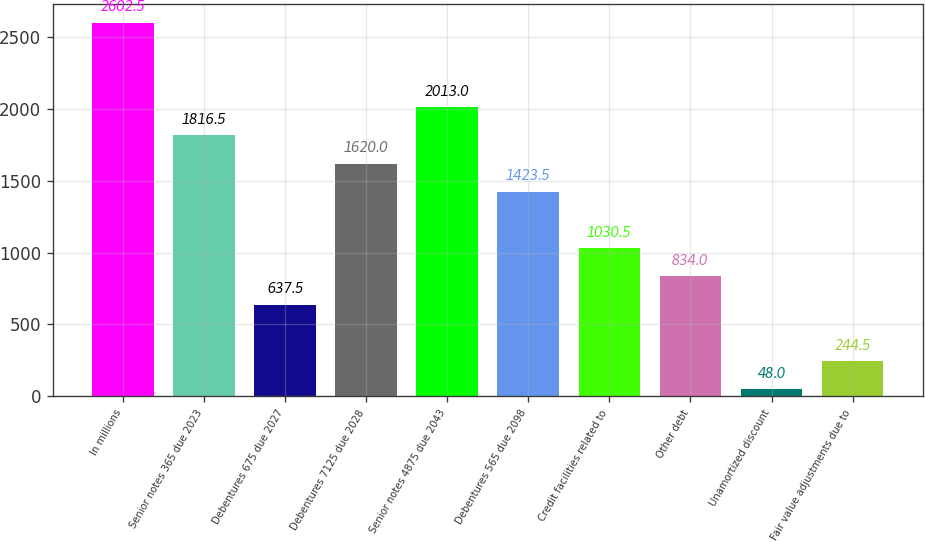<chart> <loc_0><loc_0><loc_500><loc_500><bar_chart><fcel>In millions<fcel>Senior notes 365 due 2023<fcel>Debentures 675 due 2027<fcel>Debentures 7125 due 2028<fcel>Senior notes 4875 due 2043<fcel>Debentures 565 due 2098<fcel>Credit facilities related to<fcel>Other debt<fcel>Unamortized discount<fcel>Fair value adjustments due to<nl><fcel>2602.5<fcel>1816.5<fcel>637.5<fcel>1620<fcel>2013<fcel>1423.5<fcel>1030.5<fcel>834<fcel>48<fcel>244.5<nl></chart> 